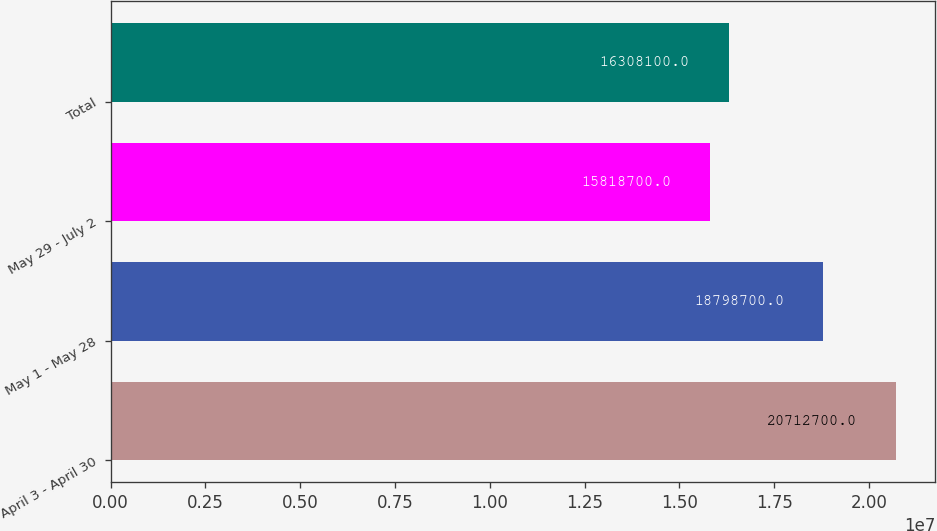Convert chart. <chart><loc_0><loc_0><loc_500><loc_500><bar_chart><fcel>April 3 - April 30<fcel>May 1 - May 28<fcel>May 29 - July 2<fcel>Total<nl><fcel>2.07127e+07<fcel>1.87987e+07<fcel>1.58187e+07<fcel>1.63081e+07<nl></chart> 